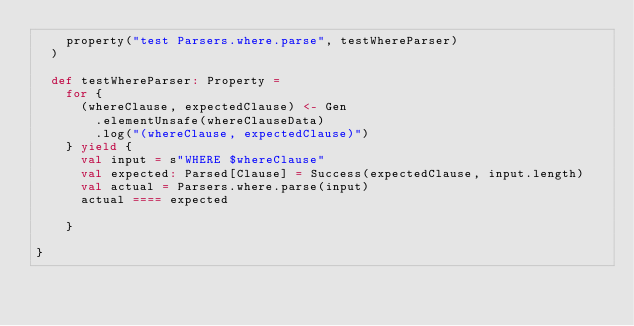Convert code to text. <code><loc_0><loc_0><loc_500><loc_500><_Scala_>    property("test Parsers.where.parse", testWhereParser)
  )

  def testWhereParser: Property =
    for {
      (whereClause, expectedClause) <- Gen
        .elementUnsafe(whereClauseData)
        .log("(whereClause, expectedClause)")
    } yield {
      val input = s"WHERE $whereClause"
      val expected: Parsed[Clause] = Success(expectedClause, input.length)
      val actual = Parsers.where.parse(input)
      actual ==== expected

    }

}
</code> 